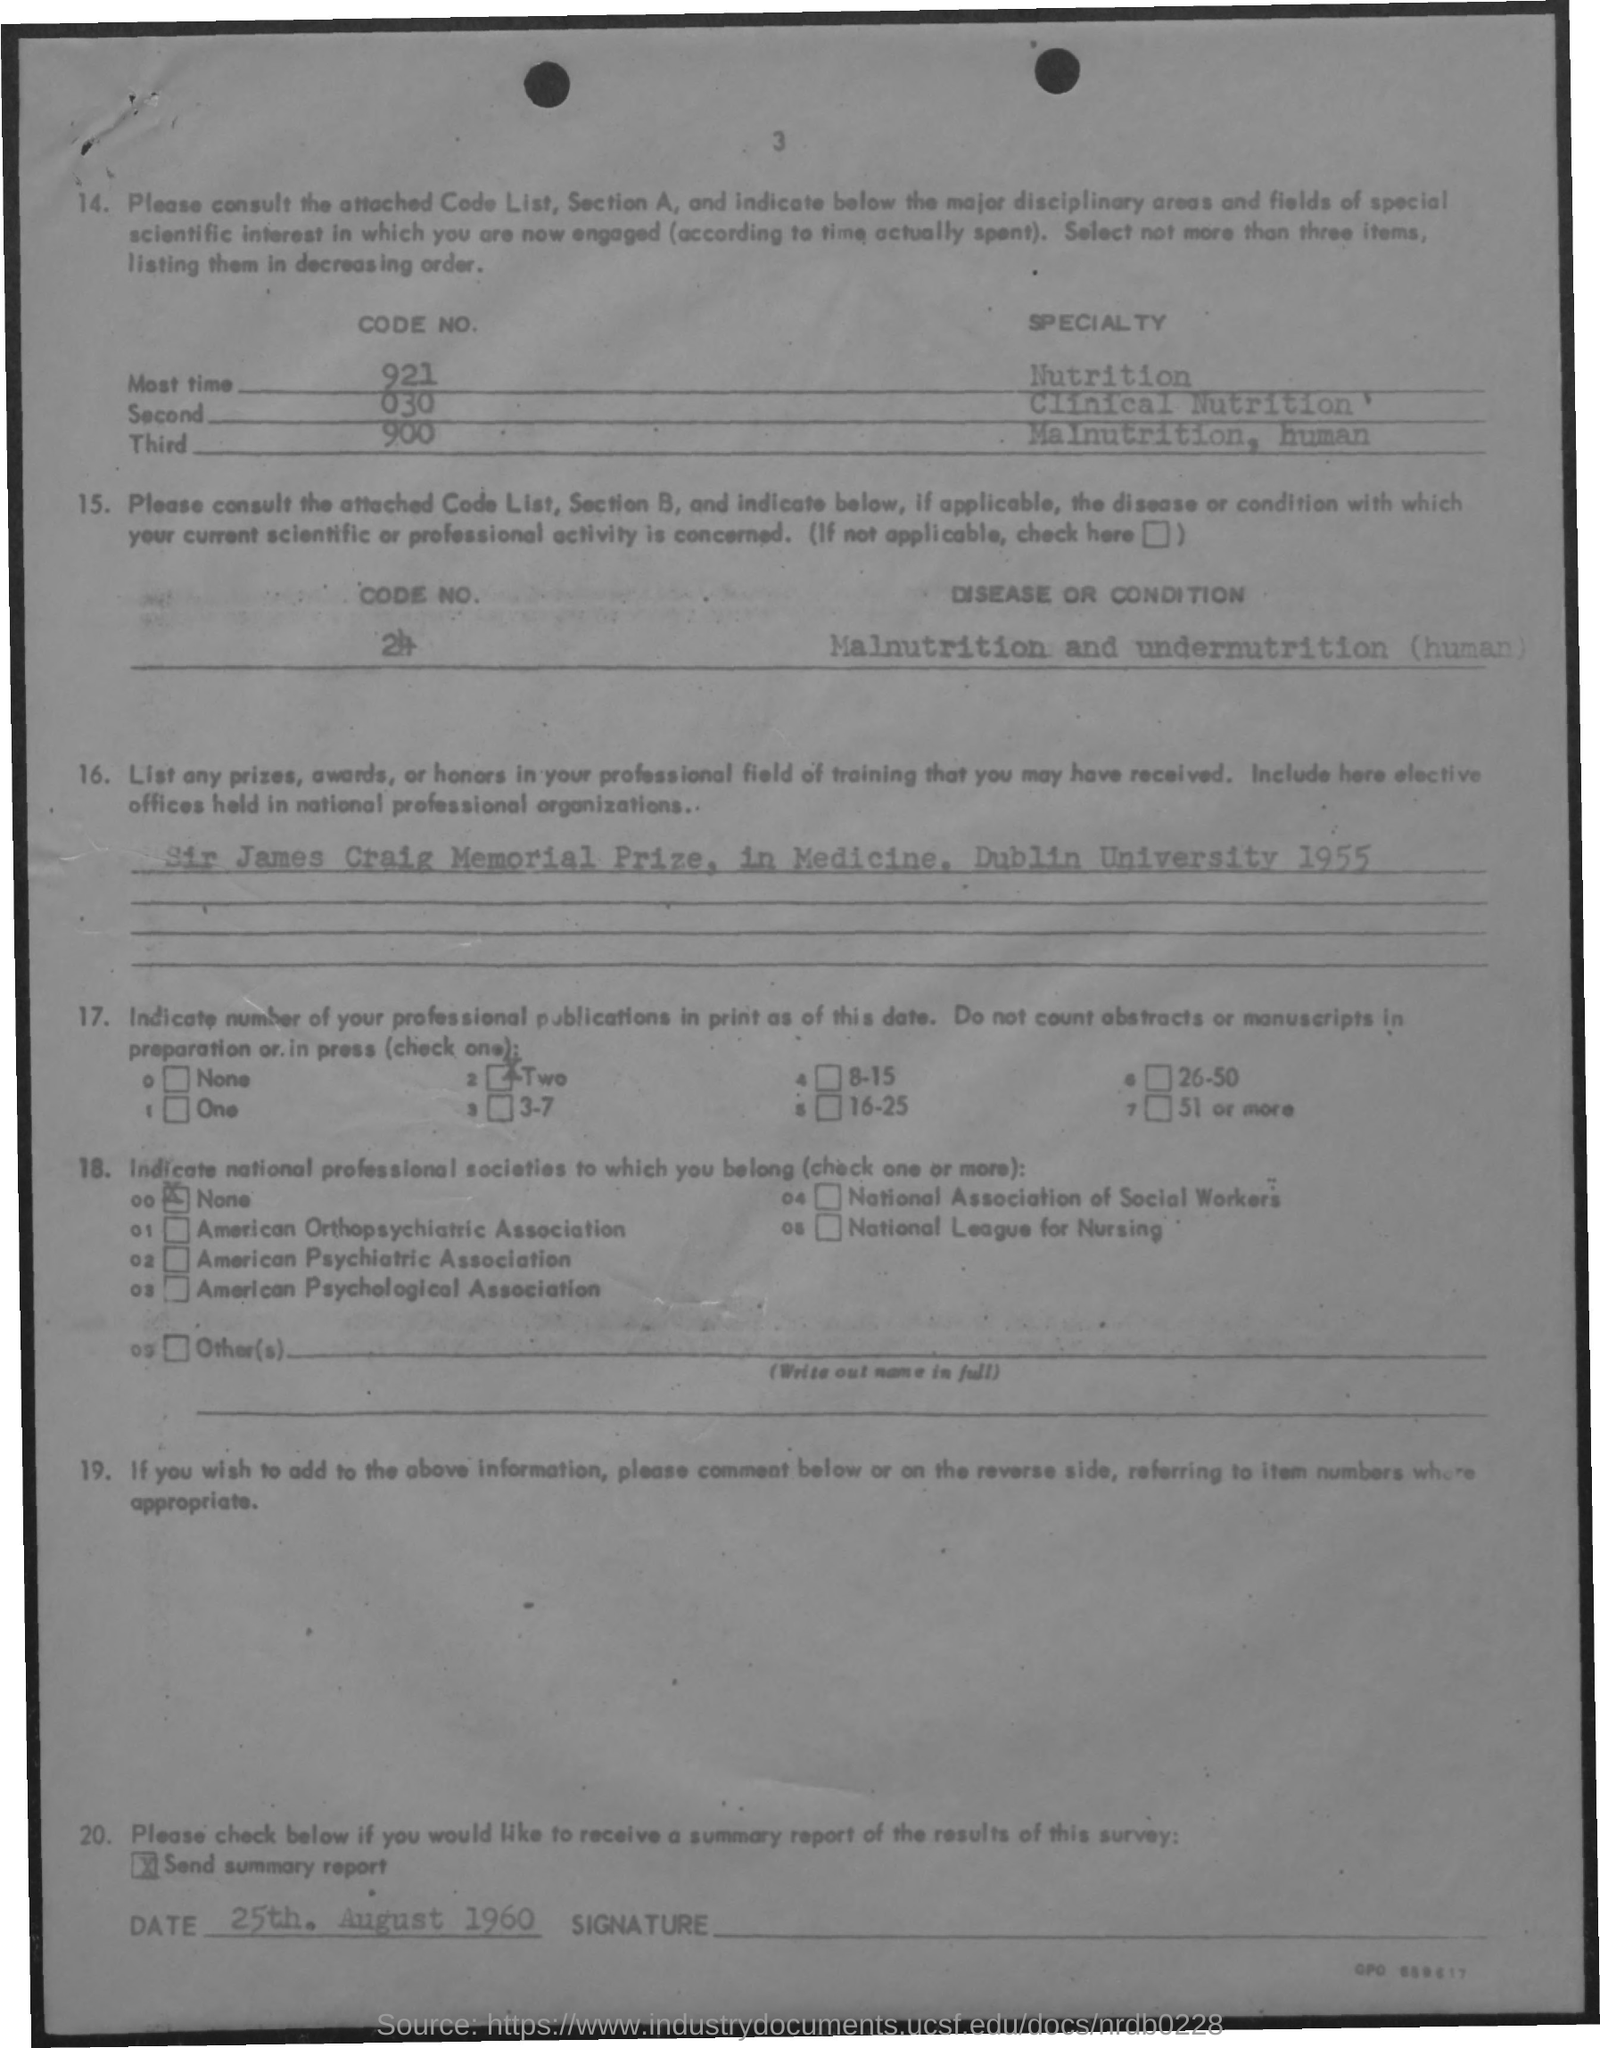What is the Page Number?
Provide a short and direct response. 3. What is the date mentioned in the document?
Provide a succinct answer. 25th. August 1960. What is the code number of "Most time"?
Offer a very short reply. 921. What is the code number of "Second"?
Provide a short and direct response. 030. What is the code number of "Third"?
Your answer should be compact. 900. What is the specialty of code number 921?
Ensure brevity in your answer.  Nutrition. What is the specialty of code number 030?
Ensure brevity in your answer.  Clinical Nutrition. 